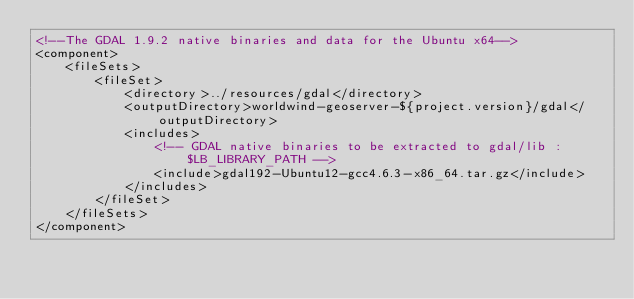Convert code to text. <code><loc_0><loc_0><loc_500><loc_500><_XML_><!--The GDAL 1.9.2 native binaries and data for the Ubuntu x64-->
<component>
    <fileSets>
        <fileSet>
            <directory>../resources/gdal</directory>
            <outputDirectory>worldwind-geoserver-${project.version}/gdal</outputDirectory>
            <includes>
                <!-- GDAL native binaries to be extracted to gdal/lib : $LB_LIBRARY_PATH -->
                <include>gdal192-Ubuntu12-gcc4.6.3-x86_64.tar.gz</include>
            </includes>            
        </fileSet>
    </fileSets>
</component></code> 